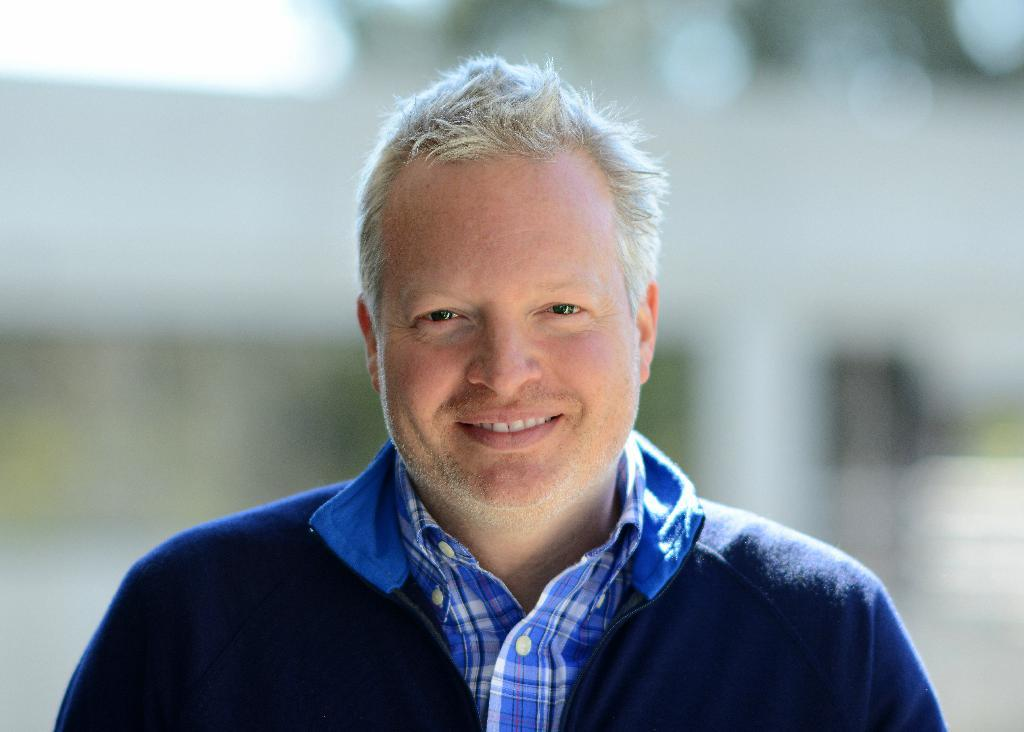What is present in the image? There is a person in the image. What is the person wearing on their upper body? The person is wearing a blue jacket and a shirt. What type of chicken is being held by the person in the image? There is no chicken present in the image. What type of gun is being used by the person in the image? There is no gun present in the image. 